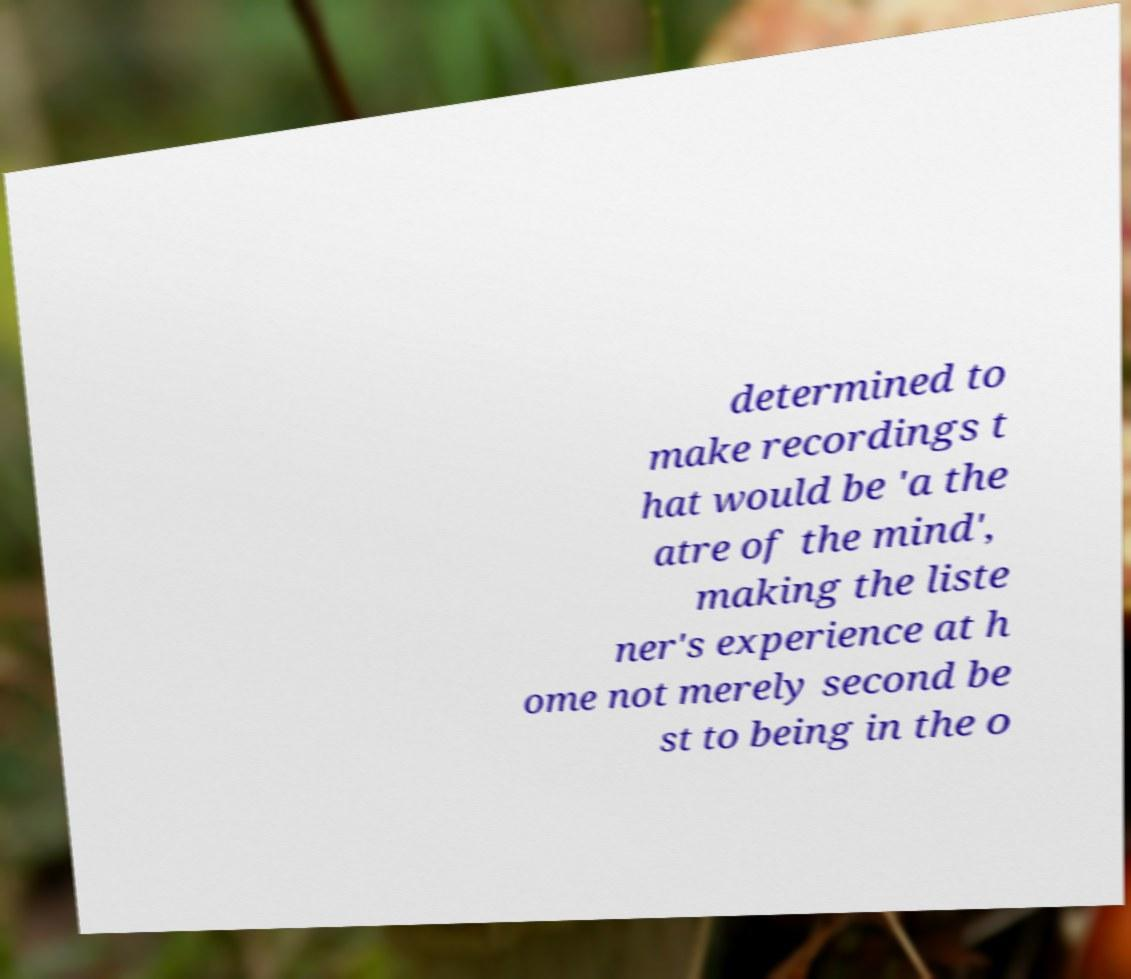Can you read and provide the text displayed in the image?This photo seems to have some interesting text. Can you extract and type it out for me? determined to make recordings t hat would be 'a the atre of the mind', making the liste ner's experience at h ome not merely second be st to being in the o 